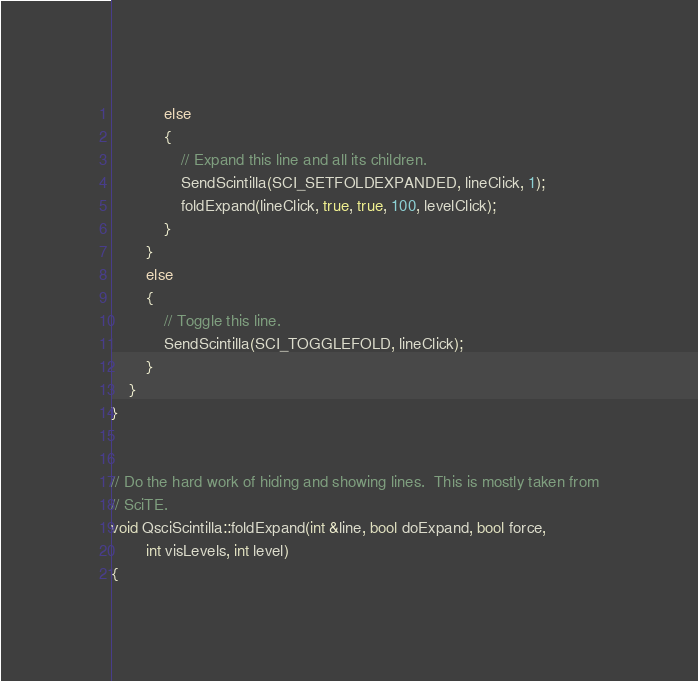Convert code to text. <code><loc_0><loc_0><loc_500><loc_500><_C++_>            else
            {
                // Expand this line and all its children.
                SendScintilla(SCI_SETFOLDEXPANDED, lineClick, 1);
                foldExpand(lineClick, true, true, 100, levelClick);
            }
        }
        else
        {
            // Toggle this line.
            SendScintilla(SCI_TOGGLEFOLD, lineClick);
        }
    }
}


// Do the hard work of hiding and showing lines.  This is mostly taken from
// SciTE.
void QsciScintilla::foldExpand(int &line, bool doExpand, bool force,
        int visLevels, int level)
{</code> 